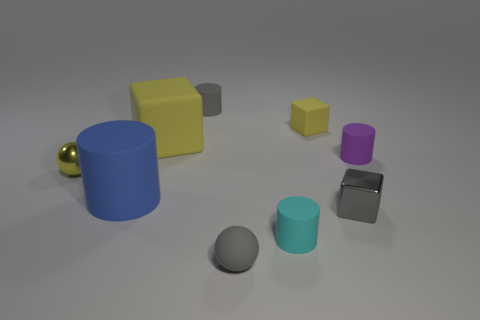Is there a cyan matte thing on the right side of the tiny yellow rubber cube behind the gray matte thing that is in front of the big yellow rubber block?
Provide a succinct answer. No. Are there any other things that are the same size as the yellow metal ball?
Make the answer very short. Yes. What is the color of the sphere that is made of the same material as the purple thing?
Make the answer very short. Gray. There is a matte object that is in front of the large yellow object and to the left of the small gray rubber cylinder; how big is it?
Give a very brief answer. Large. Are there fewer tiny gray metallic cubes on the left side of the small matte block than tiny yellow rubber things that are to the right of the gray metal thing?
Keep it short and to the point. No. Do the tiny cylinder behind the tiny matte block and the yellow thing that is to the right of the tiny matte ball have the same material?
Give a very brief answer. Yes. What material is the tiny cylinder that is the same color as the small rubber ball?
Ensure brevity in your answer.  Rubber. There is a tiny gray thing that is in front of the tiny yellow sphere and on the left side of the tiny metal block; what shape is it?
Keep it short and to the point. Sphere. The tiny gray thing that is behind the tiny matte cylinder right of the small cyan rubber cylinder is made of what material?
Ensure brevity in your answer.  Rubber. Is the number of large yellow rubber balls greater than the number of blue rubber objects?
Give a very brief answer. No. 